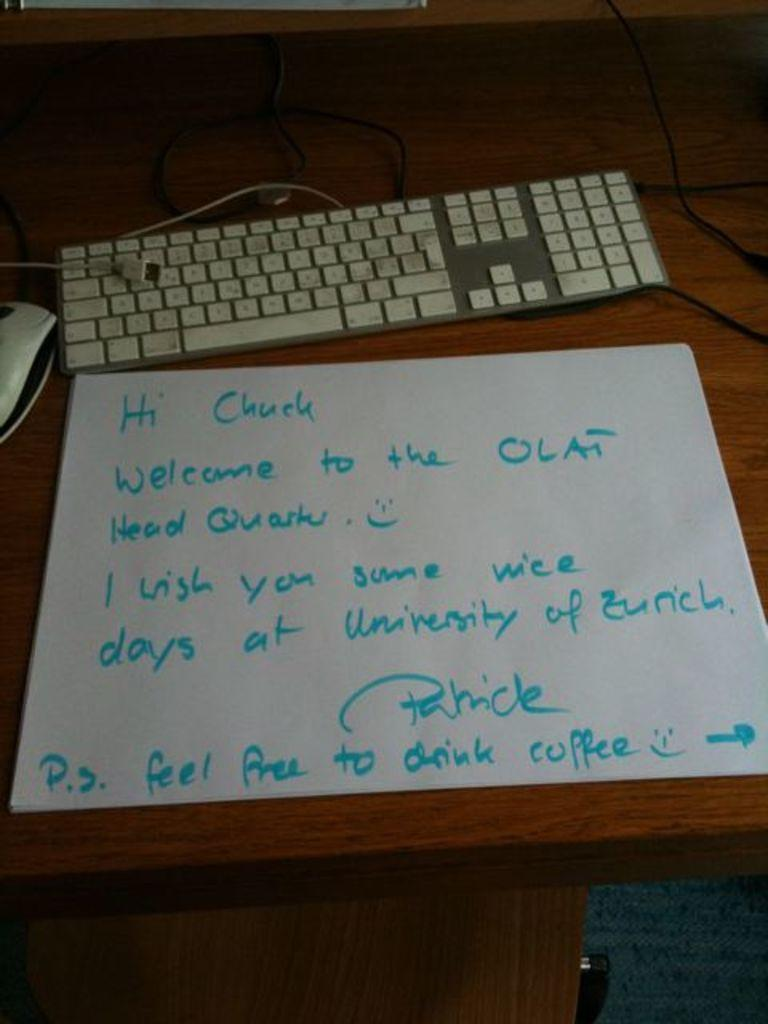<image>
Create a compact narrative representing the image presented. A note is sitting on a desk addressed to Chuck to welcome him to the university. 